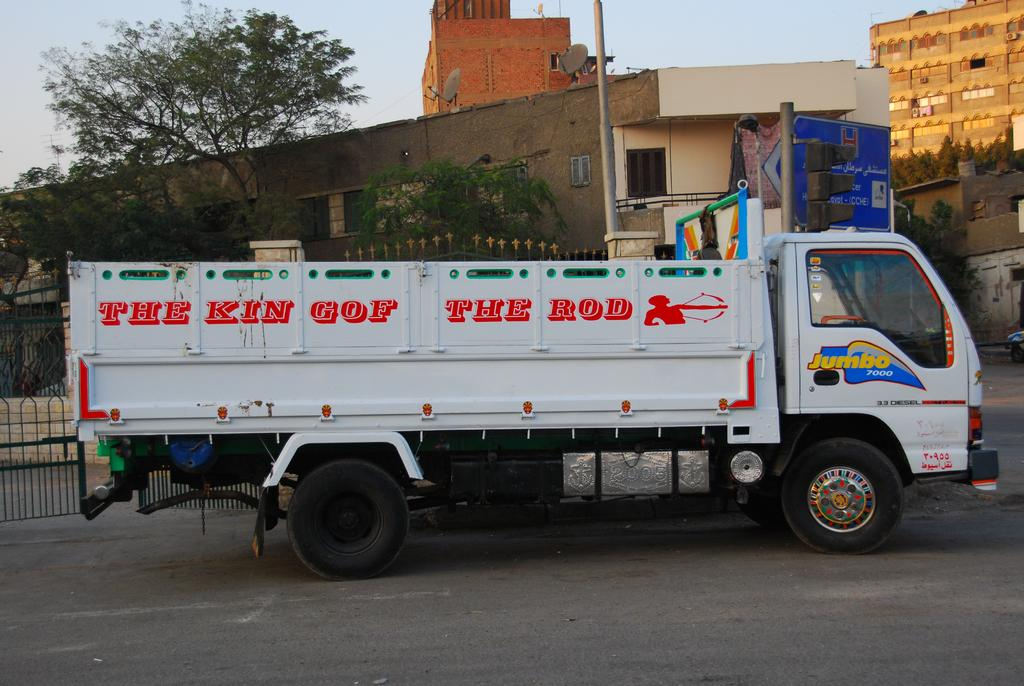<image>
Relay a brief, clear account of the picture shown. A white dump truck says The King of the Rod in red letters. 